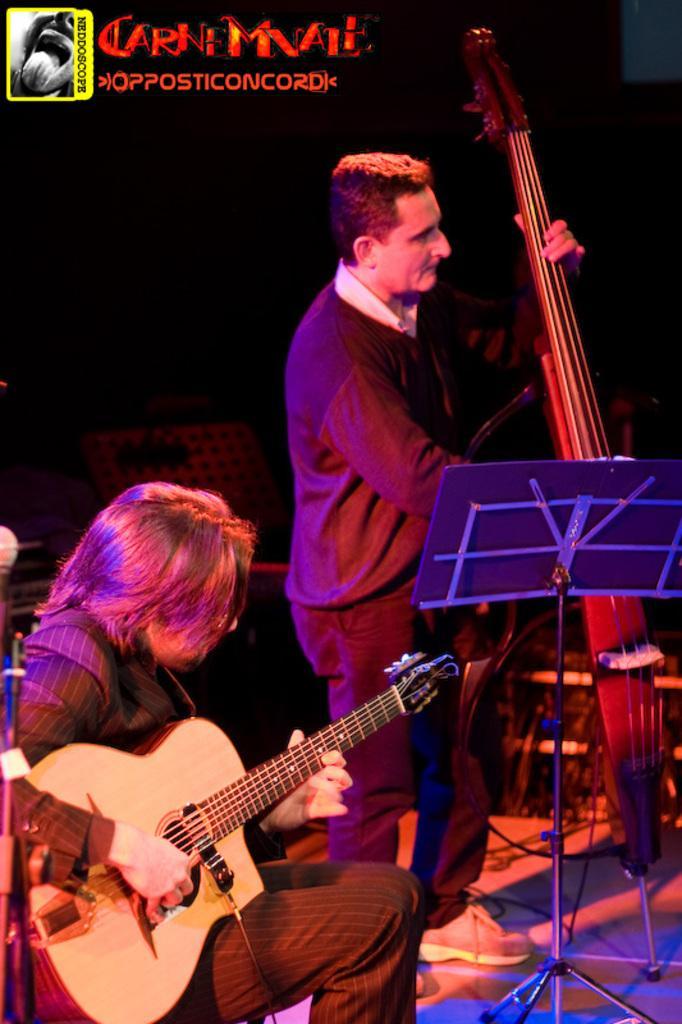In one or two sentences, can you explain what this image depicts? A man is sitting and playing guitar. Beside him there is another man standing and playing cello. 